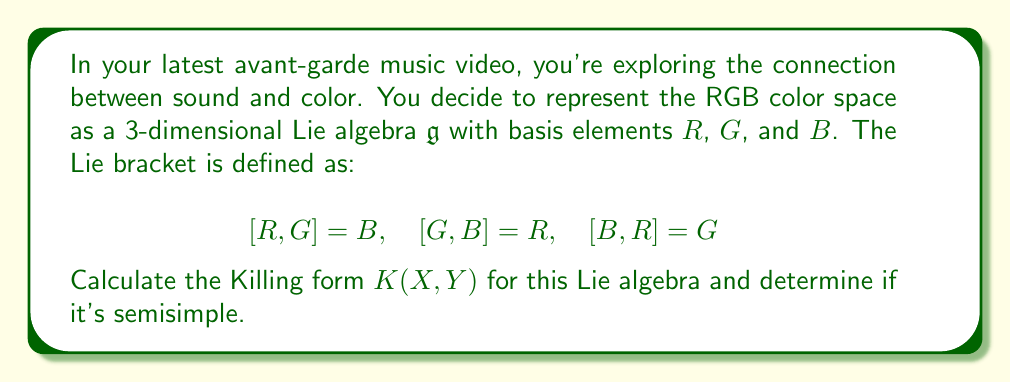Solve this math problem. To solve this problem, we'll follow these steps:

1) The Killing form is defined as $K(X,Y) = \text{tr}(\text{ad}(X) \circ \text{ad}(Y))$, where $\text{ad}(X)$ is the adjoint representation of $X$.

2) First, let's calculate the adjoint representations for $R$, $G$, and $B$:

   $\text{ad}(R) = \begin{pmatrix} 0 & 0 & -1 \\ 0 & 0 & 1 \\ 0 & -1 & 0 \end{pmatrix}$
   
   $\text{ad}(G) = \begin{pmatrix} 0 & 0 & 1 \\ -1 & 0 & 0 \\ 1 & 0 & 0 \end{pmatrix}$
   
   $\text{ad}(B) = \begin{pmatrix} 0 & 1 & 0 \\ 1 & 0 & 0 \\ 0 & 0 & 0 \end{pmatrix}$

3) Now, let's calculate $K(R,R)$, $K(G,G)$, and $K(B,B)$:

   $K(R,R) = \text{tr}(\text{ad}(R) \circ \text{ad}(R)) = -2$
   
   $K(G,G) = \text{tr}(\text{ad}(G) \circ \text{ad}(G)) = -2$
   
   $K(B,B) = \text{tr}(\text{ad}(B) \circ \text{ad}(B)) = -2$

4) For the mixed terms:

   $K(R,G) = K(G,R) = \text{tr}(\text{ad}(R) \circ \text{ad}(G)) = 0$
   
   $K(R,B) = K(B,R) = \text{tr}(\text{ad}(R) \circ \text{ad}(B)) = 0$
   
   $K(G,B) = K(B,G) = \text{tr}(\text{ad}(G) \circ \text{ad}(B)) = 0$

5) Therefore, the Killing form matrix is:

   $K = \begin{pmatrix} -2 & 0 & 0 \\ 0 & -2 & 0 \\ 0 & 0 & -2 \end{pmatrix}$

6) A Lie algebra is semisimple if and only if its Killing form is non-degenerate (i.e., has non-zero determinant).

   $\det(K) = (-2)^3 = -8 \neq 0$

Thus, the Killing form is non-degenerate, and the Lie algebra is semisimple.
Answer: The Killing form for the given Lie algebra is $K = \begin{pmatrix} -2 & 0 & 0 \\ 0 & -2 & 0 \\ 0 & 0 & -2 \end{pmatrix}$. The Lie algebra is semisimple because the Killing form is non-degenerate. 